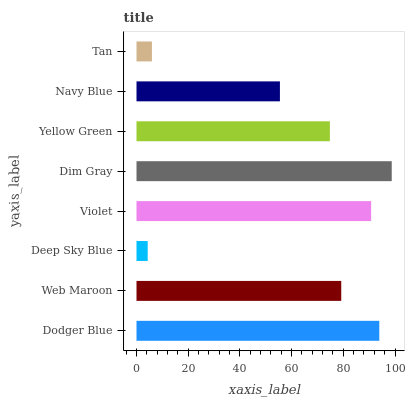Is Deep Sky Blue the minimum?
Answer yes or no. Yes. Is Dim Gray the maximum?
Answer yes or no. Yes. Is Web Maroon the minimum?
Answer yes or no. No. Is Web Maroon the maximum?
Answer yes or no. No. Is Dodger Blue greater than Web Maroon?
Answer yes or no. Yes. Is Web Maroon less than Dodger Blue?
Answer yes or no. Yes. Is Web Maroon greater than Dodger Blue?
Answer yes or no. No. Is Dodger Blue less than Web Maroon?
Answer yes or no. No. Is Web Maroon the high median?
Answer yes or no. Yes. Is Yellow Green the low median?
Answer yes or no. Yes. Is Navy Blue the high median?
Answer yes or no. No. Is Navy Blue the low median?
Answer yes or no. No. 